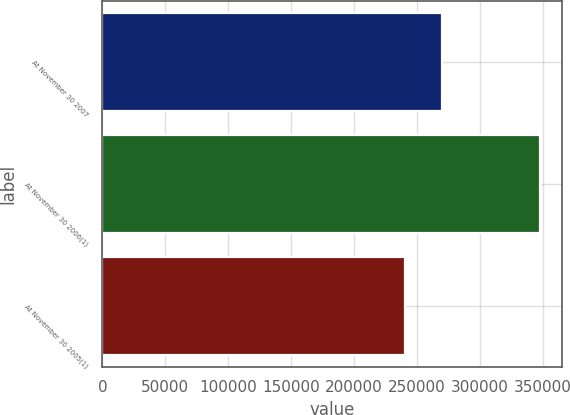<chart> <loc_0><loc_0><loc_500><loc_500><bar_chart><fcel>At November 30 2007<fcel>At November 30 2006(1)<fcel>At November 30 2005(1)<nl><fcel>269753<fcel>347379<fcel>240467<nl></chart> 